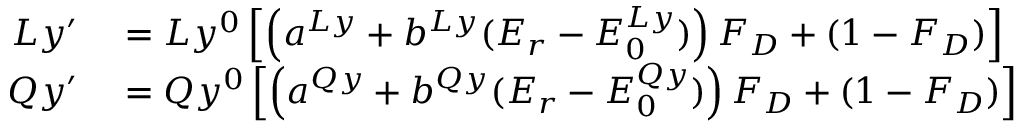Convert formula to latex. <formula><loc_0><loc_0><loc_500><loc_500>\begin{array} { r l } { L y ^ { \prime } } & = L y ^ { 0 } \left [ \left ( a ^ { L y } + b ^ { L y } ( E _ { r } - E _ { 0 } ^ { L y } ) \right ) F _ { D } + ( 1 - F _ { D } ) \right ] } \\ { Q y ^ { \prime } } & = Q y ^ { 0 } \left [ \left ( a ^ { Q y } + b ^ { Q y } ( E _ { r } - E _ { 0 } ^ { Q y } ) \right ) F _ { D } + ( 1 - F _ { D } ) \right ] } \end{array}</formula> 